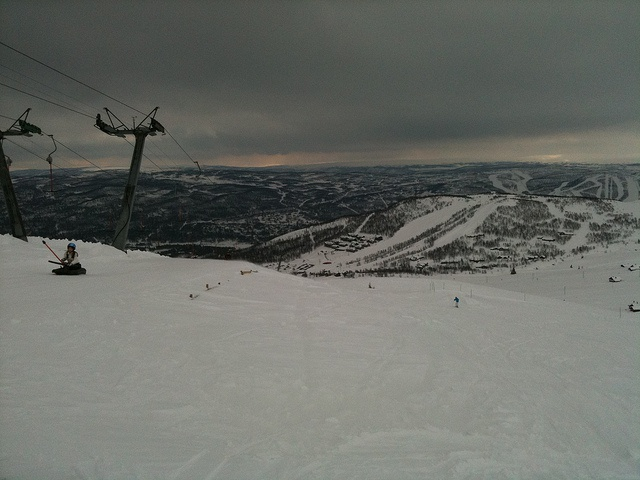Describe the objects in this image and their specific colors. I can see people in black and gray tones, people in black, gray, and darkblue tones, and skis in gray and black tones in this image. 